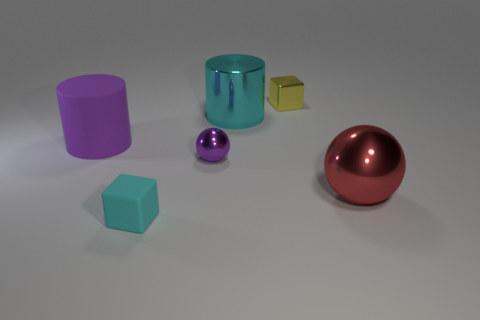Add 1 big metallic cylinders. How many objects exist? 7 Subtract 1 red balls. How many objects are left? 5 Subtract 1 cylinders. How many cylinders are left? 1 Subtract all blue balls. Subtract all purple cylinders. How many balls are left? 2 Subtract all red objects. Subtract all cyan rubber things. How many objects are left? 4 Add 2 matte blocks. How many matte blocks are left? 3 Add 2 spheres. How many spheres exist? 4 